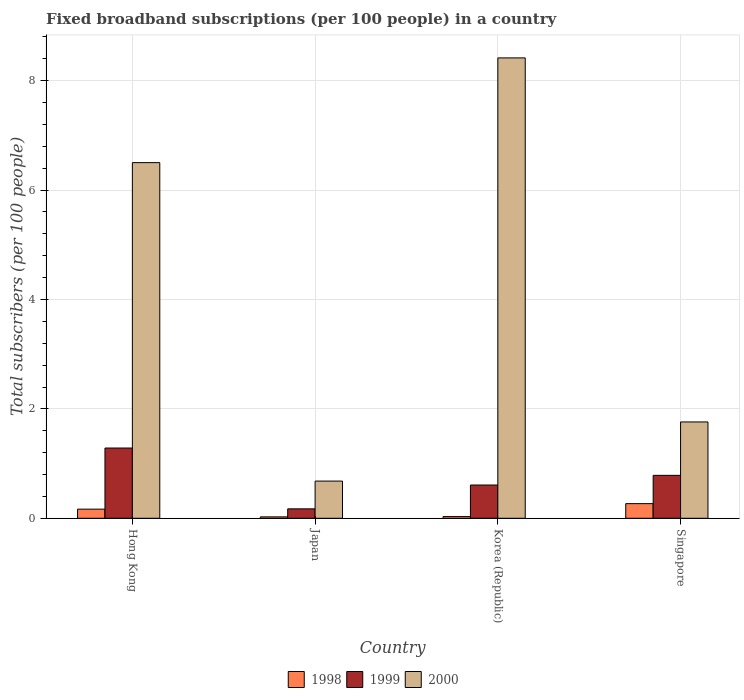How many groups of bars are there?
Your answer should be very brief. 4. How many bars are there on the 4th tick from the left?
Provide a succinct answer. 3. How many bars are there on the 4th tick from the right?
Your answer should be very brief. 3. What is the label of the 3rd group of bars from the left?
Give a very brief answer. Korea (Republic). In how many cases, is the number of bars for a given country not equal to the number of legend labels?
Offer a terse response. 0. What is the number of broadband subscriptions in 1998 in Singapore?
Your answer should be very brief. 0.27. Across all countries, what is the maximum number of broadband subscriptions in 1999?
Make the answer very short. 1.28. Across all countries, what is the minimum number of broadband subscriptions in 1998?
Keep it short and to the point. 0.03. In which country was the number of broadband subscriptions in 1999 maximum?
Give a very brief answer. Hong Kong. What is the total number of broadband subscriptions in 1998 in the graph?
Provide a short and direct response. 0.49. What is the difference between the number of broadband subscriptions in 2000 in Hong Kong and that in Korea (Republic)?
Ensure brevity in your answer.  -1.91. What is the difference between the number of broadband subscriptions in 1999 in Japan and the number of broadband subscriptions in 2000 in Korea (Republic)?
Make the answer very short. -8.25. What is the average number of broadband subscriptions in 1999 per country?
Your answer should be compact. 0.71. What is the difference between the number of broadband subscriptions of/in 2000 and number of broadband subscriptions of/in 1998 in Japan?
Ensure brevity in your answer.  0.65. In how many countries, is the number of broadband subscriptions in 2000 greater than 3.6?
Your answer should be compact. 2. What is the ratio of the number of broadband subscriptions in 2000 in Korea (Republic) to that in Singapore?
Provide a short and direct response. 4.78. Is the difference between the number of broadband subscriptions in 2000 in Korea (Republic) and Singapore greater than the difference between the number of broadband subscriptions in 1998 in Korea (Republic) and Singapore?
Make the answer very short. Yes. What is the difference between the highest and the second highest number of broadband subscriptions in 1999?
Offer a terse response. -0.5. What is the difference between the highest and the lowest number of broadband subscriptions in 1999?
Your response must be concise. 1.11. In how many countries, is the number of broadband subscriptions in 2000 greater than the average number of broadband subscriptions in 2000 taken over all countries?
Your answer should be compact. 2. What does the 2nd bar from the left in Japan represents?
Your response must be concise. 1999. Are all the bars in the graph horizontal?
Your answer should be compact. No. What is the difference between two consecutive major ticks on the Y-axis?
Offer a very short reply. 2. How many legend labels are there?
Provide a short and direct response. 3. What is the title of the graph?
Keep it short and to the point. Fixed broadband subscriptions (per 100 people) in a country. Does "1969" appear as one of the legend labels in the graph?
Make the answer very short. No. What is the label or title of the Y-axis?
Your answer should be very brief. Total subscribers (per 100 people). What is the Total subscribers (per 100 people) of 1998 in Hong Kong?
Your answer should be very brief. 0.17. What is the Total subscribers (per 100 people) in 1999 in Hong Kong?
Make the answer very short. 1.28. What is the Total subscribers (per 100 people) of 2000 in Hong Kong?
Your answer should be compact. 6.5. What is the Total subscribers (per 100 people) of 1998 in Japan?
Ensure brevity in your answer.  0.03. What is the Total subscribers (per 100 people) of 1999 in Japan?
Offer a very short reply. 0.17. What is the Total subscribers (per 100 people) in 2000 in Japan?
Ensure brevity in your answer.  0.68. What is the Total subscribers (per 100 people) of 1998 in Korea (Republic)?
Make the answer very short. 0.03. What is the Total subscribers (per 100 people) in 1999 in Korea (Republic)?
Your answer should be compact. 0.61. What is the Total subscribers (per 100 people) of 2000 in Korea (Republic)?
Give a very brief answer. 8.42. What is the Total subscribers (per 100 people) in 1998 in Singapore?
Your answer should be compact. 0.27. What is the Total subscribers (per 100 people) in 1999 in Singapore?
Keep it short and to the point. 0.78. What is the Total subscribers (per 100 people) in 2000 in Singapore?
Ensure brevity in your answer.  1.76. Across all countries, what is the maximum Total subscribers (per 100 people) of 1998?
Your answer should be compact. 0.27. Across all countries, what is the maximum Total subscribers (per 100 people) in 1999?
Keep it short and to the point. 1.28. Across all countries, what is the maximum Total subscribers (per 100 people) of 2000?
Your response must be concise. 8.42. Across all countries, what is the minimum Total subscribers (per 100 people) in 1998?
Give a very brief answer. 0.03. Across all countries, what is the minimum Total subscribers (per 100 people) of 1999?
Keep it short and to the point. 0.17. Across all countries, what is the minimum Total subscribers (per 100 people) of 2000?
Make the answer very short. 0.68. What is the total Total subscribers (per 100 people) in 1998 in the graph?
Offer a terse response. 0.49. What is the total Total subscribers (per 100 people) of 1999 in the graph?
Provide a succinct answer. 2.85. What is the total Total subscribers (per 100 people) in 2000 in the graph?
Give a very brief answer. 17.36. What is the difference between the Total subscribers (per 100 people) of 1998 in Hong Kong and that in Japan?
Ensure brevity in your answer.  0.14. What is the difference between the Total subscribers (per 100 people) in 1999 in Hong Kong and that in Japan?
Keep it short and to the point. 1.11. What is the difference between the Total subscribers (per 100 people) of 2000 in Hong Kong and that in Japan?
Your response must be concise. 5.82. What is the difference between the Total subscribers (per 100 people) in 1998 in Hong Kong and that in Korea (Republic)?
Provide a short and direct response. 0.14. What is the difference between the Total subscribers (per 100 people) in 1999 in Hong Kong and that in Korea (Republic)?
Your answer should be very brief. 0.68. What is the difference between the Total subscribers (per 100 people) of 2000 in Hong Kong and that in Korea (Republic)?
Offer a very short reply. -1.91. What is the difference between the Total subscribers (per 100 people) of 1998 in Hong Kong and that in Singapore?
Provide a short and direct response. -0.1. What is the difference between the Total subscribers (per 100 people) in 1999 in Hong Kong and that in Singapore?
Provide a short and direct response. 0.5. What is the difference between the Total subscribers (per 100 people) in 2000 in Hong Kong and that in Singapore?
Provide a short and direct response. 4.74. What is the difference between the Total subscribers (per 100 people) in 1998 in Japan and that in Korea (Republic)?
Provide a short and direct response. -0.01. What is the difference between the Total subscribers (per 100 people) in 1999 in Japan and that in Korea (Republic)?
Your answer should be compact. -0.44. What is the difference between the Total subscribers (per 100 people) in 2000 in Japan and that in Korea (Republic)?
Offer a terse response. -7.74. What is the difference between the Total subscribers (per 100 people) in 1998 in Japan and that in Singapore?
Your answer should be very brief. -0.24. What is the difference between the Total subscribers (per 100 people) in 1999 in Japan and that in Singapore?
Offer a terse response. -0.61. What is the difference between the Total subscribers (per 100 people) in 2000 in Japan and that in Singapore?
Keep it short and to the point. -1.08. What is the difference between the Total subscribers (per 100 people) of 1998 in Korea (Republic) and that in Singapore?
Your response must be concise. -0.24. What is the difference between the Total subscribers (per 100 people) of 1999 in Korea (Republic) and that in Singapore?
Keep it short and to the point. -0.18. What is the difference between the Total subscribers (per 100 people) of 2000 in Korea (Republic) and that in Singapore?
Make the answer very short. 6.66. What is the difference between the Total subscribers (per 100 people) in 1998 in Hong Kong and the Total subscribers (per 100 people) in 1999 in Japan?
Offer a terse response. -0.01. What is the difference between the Total subscribers (per 100 people) of 1998 in Hong Kong and the Total subscribers (per 100 people) of 2000 in Japan?
Your answer should be very brief. -0.51. What is the difference between the Total subscribers (per 100 people) of 1999 in Hong Kong and the Total subscribers (per 100 people) of 2000 in Japan?
Offer a very short reply. 0.6. What is the difference between the Total subscribers (per 100 people) of 1998 in Hong Kong and the Total subscribers (per 100 people) of 1999 in Korea (Republic)?
Provide a succinct answer. -0.44. What is the difference between the Total subscribers (per 100 people) in 1998 in Hong Kong and the Total subscribers (per 100 people) in 2000 in Korea (Republic)?
Make the answer very short. -8.25. What is the difference between the Total subscribers (per 100 people) of 1999 in Hong Kong and the Total subscribers (per 100 people) of 2000 in Korea (Republic)?
Make the answer very short. -7.13. What is the difference between the Total subscribers (per 100 people) of 1998 in Hong Kong and the Total subscribers (per 100 people) of 1999 in Singapore?
Provide a short and direct response. -0.62. What is the difference between the Total subscribers (per 100 people) in 1998 in Hong Kong and the Total subscribers (per 100 people) in 2000 in Singapore?
Offer a very short reply. -1.59. What is the difference between the Total subscribers (per 100 people) in 1999 in Hong Kong and the Total subscribers (per 100 people) in 2000 in Singapore?
Give a very brief answer. -0.48. What is the difference between the Total subscribers (per 100 people) in 1998 in Japan and the Total subscribers (per 100 people) in 1999 in Korea (Republic)?
Keep it short and to the point. -0.58. What is the difference between the Total subscribers (per 100 people) in 1998 in Japan and the Total subscribers (per 100 people) in 2000 in Korea (Republic)?
Your answer should be compact. -8.39. What is the difference between the Total subscribers (per 100 people) in 1999 in Japan and the Total subscribers (per 100 people) in 2000 in Korea (Republic)?
Your response must be concise. -8.25. What is the difference between the Total subscribers (per 100 people) in 1998 in Japan and the Total subscribers (per 100 people) in 1999 in Singapore?
Provide a succinct answer. -0.76. What is the difference between the Total subscribers (per 100 people) in 1998 in Japan and the Total subscribers (per 100 people) in 2000 in Singapore?
Keep it short and to the point. -1.74. What is the difference between the Total subscribers (per 100 people) in 1999 in Japan and the Total subscribers (per 100 people) in 2000 in Singapore?
Your answer should be compact. -1.59. What is the difference between the Total subscribers (per 100 people) of 1998 in Korea (Republic) and the Total subscribers (per 100 people) of 1999 in Singapore?
Your answer should be compact. -0.75. What is the difference between the Total subscribers (per 100 people) of 1998 in Korea (Republic) and the Total subscribers (per 100 people) of 2000 in Singapore?
Provide a short and direct response. -1.73. What is the difference between the Total subscribers (per 100 people) in 1999 in Korea (Republic) and the Total subscribers (per 100 people) in 2000 in Singapore?
Your answer should be very brief. -1.15. What is the average Total subscribers (per 100 people) in 1998 per country?
Your answer should be very brief. 0.12. What is the average Total subscribers (per 100 people) of 1999 per country?
Offer a terse response. 0.71. What is the average Total subscribers (per 100 people) of 2000 per country?
Your response must be concise. 4.34. What is the difference between the Total subscribers (per 100 people) of 1998 and Total subscribers (per 100 people) of 1999 in Hong Kong?
Provide a succinct answer. -1.12. What is the difference between the Total subscribers (per 100 people) in 1998 and Total subscribers (per 100 people) in 2000 in Hong Kong?
Give a very brief answer. -6.34. What is the difference between the Total subscribers (per 100 people) in 1999 and Total subscribers (per 100 people) in 2000 in Hong Kong?
Your answer should be very brief. -5.22. What is the difference between the Total subscribers (per 100 people) in 1998 and Total subscribers (per 100 people) in 1999 in Japan?
Your response must be concise. -0.15. What is the difference between the Total subscribers (per 100 people) in 1998 and Total subscribers (per 100 people) in 2000 in Japan?
Your answer should be very brief. -0.65. What is the difference between the Total subscribers (per 100 people) of 1999 and Total subscribers (per 100 people) of 2000 in Japan?
Provide a succinct answer. -0.51. What is the difference between the Total subscribers (per 100 people) of 1998 and Total subscribers (per 100 people) of 1999 in Korea (Republic)?
Your answer should be compact. -0.58. What is the difference between the Total subscribers (per 100 people) in 1998 and Total subscribers (per 100 people) in 2000 in Korea (Republic)?
Ensure brevity in your answer.  -8.39. What is the difference between the Total subscribers (per 100 people) in 1999 and Total subscribers (per 100 people) in 2000 in Korea (Republic)?
Provide a short and direct response. -7.81. What is the difference between the Total subscribers (per 100 people) in 1998 and Total subscribers (per 100 people) in 1999 in Singapore?
Keep it short and to the point. -0.52. What is the difference between the Total subscribers (per 100 people) of 1998 and Total subscribers (per 100 people) of 2000 in Singapore?
Your answer should be very brief. -1.49. What is the difference between the Total subscribers (per 100 people) of 1999 and Total subscribers (per 100 people) of 2000 in Singapore?
Provide a short and direct response. -0.98. What is the ratio of the Total subscribers (per 100 people) in 1998 in Hong Kong to that in Japan?
Give a very brief answer. 6.53. What is the ratio of the Total subscribers (per 100 people) of 1999 in Hong Kong to that in Japan?
Make the answer very short. 7.46. What is the ratio of the Total subscribers (per 100 people) of 2000 in Hong Kong to that in Japan?
Ensure brevity in your answer.  9.56. What is the ratio of the Total subscribers (per 100 people) of 1998 in Hong Kong to that in Korea (Republic)?
Offer a very short reply. 5.42. What is the ratio of the Total subscribers (per 100 people) in 1999 in Hong Kong to that in Korea (Republic)?
Your answer should be compact. 2.11. What is the ratio of the Total subscribers (per 100 people) of 2000 in Hong Kong to that in Korea (Republic)?
Make the answer very short. 0.77. What is the ratio of the Total subscribers (per 100 people) of 1998 in Hong Kong to that in Singapore?
Your answer should be very brief. 0.62. What is the ratio of the Total subscribers (per 100 people) in 1999 in Hong Kong to that in Singapore?
Keep it short and to the point. 1.64. What is the ratio of the Total subscribers (per 100 people) in 2000 in Hong Kong to that in Singapore?
Offer a terse response. 3.69. What is the ratio of the Total subscribers (per 100 people) in 1998 in Japan to that in Korea (Republic)?
Your answer should be compact. 0.83. What is the ratio of the Total subscribers (per 100 people) in 1999 in Japan to that in Korea (Republic)?
Your answer should be compact. 0.28. What is the ratio of the Total subscribers (per 100 people) of 2000 in Japan to that in Korea (Republic)?
Keep it short and to the point. 0.08. What is the ratio of the Total subscribers (per 100 people) of 1998 in Japan to that in Singapore?
Ensure brevity in your answer.  0.1. What is the ratio of the Total subscribers (per 100 people) in 1999 in Japan to that in Singapore?
Make the answer very short. 0.22. What is the ratio of the Total subscribers (per 100 people) of 2000 in Japan to that in Singapore?
Offer a terse response. 0.39. What is the ratio of the Total subscribers (per 100 people) of 1998 in Korea (Republic) to that in Singapore?
Your response must be concise. 0.12. What is the ratio of the Total subscribers (per 100 people) of 1999 in Korea (Republic) to that in Singapore?
Give a very brief answer. 0.77. What is the ratio of the Total subscribers (per 100 people) of 2000 in Korea (Republic) to that in Singapore?
Your answer should be very brief. 4.78. What is the difference between the highest and the second highest Total subscribers (per 100 people) in 1998?
Provide a succinct answer. 0.1. What is the difference between the highest and the second highest Total subscribers (per 100 people) of 1999?
Your answer should be compact. 0.5. What is the difference between the highest and the second highest Total subscribers (per 100 people) in 2000?
Your response must be concise. 1.91. What is the difference between the highest and the lowest Total subscribers (per 100 people) in 1998?
Offer a very short reply. 0.24. What is the difference between the highest and the lowest Total subscribers (per 100 people) of 1999?
Ensure brevity in your answer.  1.11. What is the difference between the highest and the lowest Total subscribers (per 100 people) in 2000?
Provide a short and direct response. 7.74. 